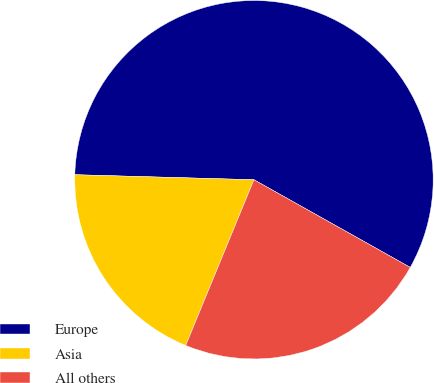Convert chart to OTSL. <chart><loc_0><loc_0><loc_500><loc_500><pie_chart><fcel>Europe<fcel>Asia<fcel>All others<nl><fcel>57.69%<fcel>19.23%<fcel>23.08%<nl></chart> 